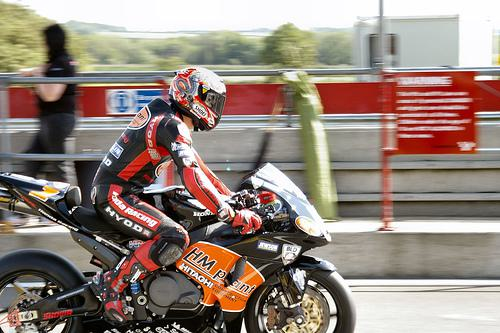Would there be a motorbike in the image once the motorbike has been removed from the scene? After removing the motorbike from the image, it would no longer be present. The scene would then consist of just the background elements, such as the track, any surrounding scenery or objects, and potentially the rider if they were not considered part of the motorbike entity. 